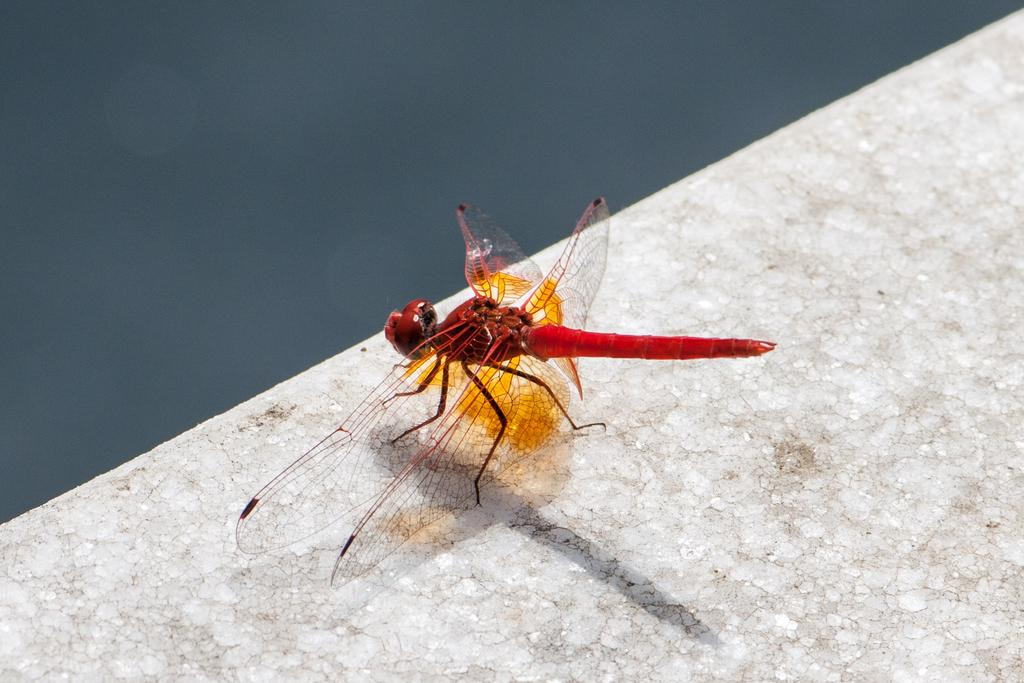What is present in the image? There is a fly in the image. What is the fly lying on? The fly is lying on a stone surface. What type of pencil can be seen in the image? There is no pencil present in the image; it only features a fly lying on a stone surface. 